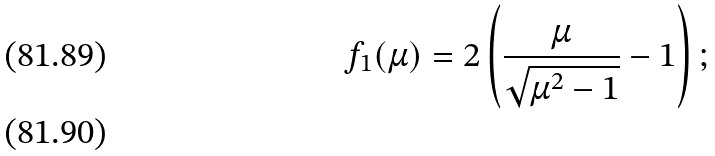<formula> <loc_0><loc_0><loc_500><loc_500>f _ { 1 } ( { \mu } ) = 2 \left ( \frac { \mu } { \sqrt { { \mu } ^ { 2 } - 1 } } - 1 \right ) ; \\</formula> 